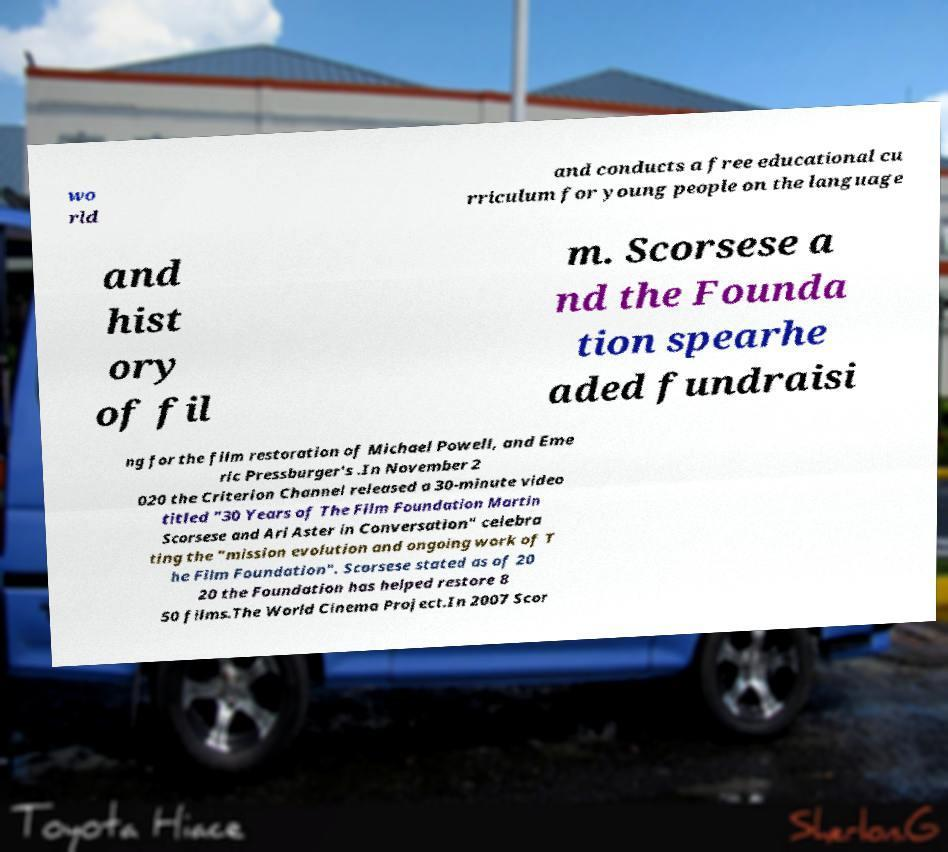Can you accurately transcribe the text from the provided image for me? wo rld and conducts a free educational cu rriculum for young people on the language and hist ory of fil m. Scorsese a nd the Founda tion spearhe aded fundraisi ng for the film restoration of Michael Powell, and Eme ric Pressburger's .In November 2 020 the Criterion Channel released a 30-minute video titled "30 Years of The Film Foundation Martin Scorsese and Ari Aster in Conversation" celebra ting the "mission evolution and ongoing work of T he Film Foundation". Scorsese stated as of 20 20 the Foundation has helped restore 8 50 films.The World Cinema Project.In 2007 Scor 